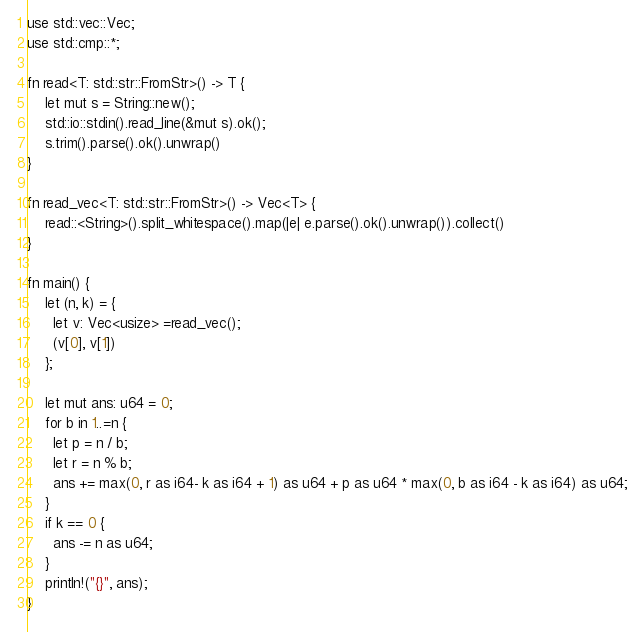<code> <loc_0><loc_0><loc_500><loc_500><_Rust_>use std::vec::Vec;
use std::cmp::*;

fn read<T: std::str::FromStr>() -> T {
    let mut s = String::new();
    std::io::stdin().read_line(&mut s).ok();
    s.trim().parse().ok().unwrap()
}

fn read_vec<T: std::str::FromStr>() -> Vec<T> {
    read::<String>().split_whitespace().map(|e| e.parse().ok().unwrap()).collect()
}

fn main() {
    let (n, k) = {
      let v: Vec<usize> =read_vec();
      (v[0], v[1])
    };

    let mut ans: u64 = 0;
    for b in 1..=n {
      let p = n / b;
      let r = n % b;
      ans += max(0, r as i64- k as i64 + 1) as u64 + p as u64 * max(0, b as i64 - k as i64) as u64;
    }
    if k == 0 {
      ans -= n as u64;
    }
    println!("{}", ans);
}
</code> 